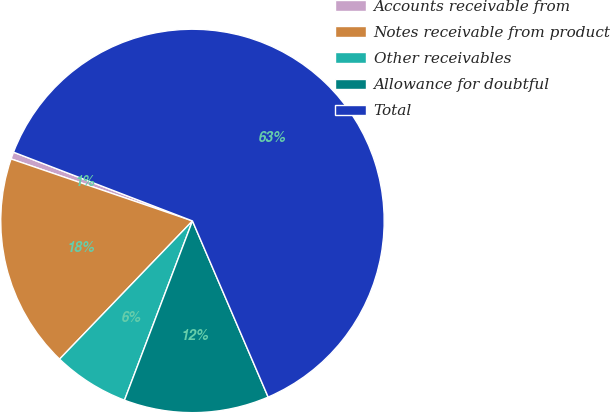Convert chart to OTSL. <chart><loc_0><loc_0><loc_500><loc_500><pie_chart><fcel>Accounts receivable from<fcel>Notes receivable from product<fcel>Other receivables<fcel>Allowance for doubtful<fcel>Total<nl><fcel>0.6%<fcel>18.05%<fcel>6.42%<fcel>12.23%<fcel>62.7%<nl></chart> 